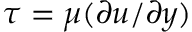Convert formula to latex. <formula><loc_0><loc_0><loc_500><loc_500>\tau = \mu ( \partial u / \partial y )</formula> 